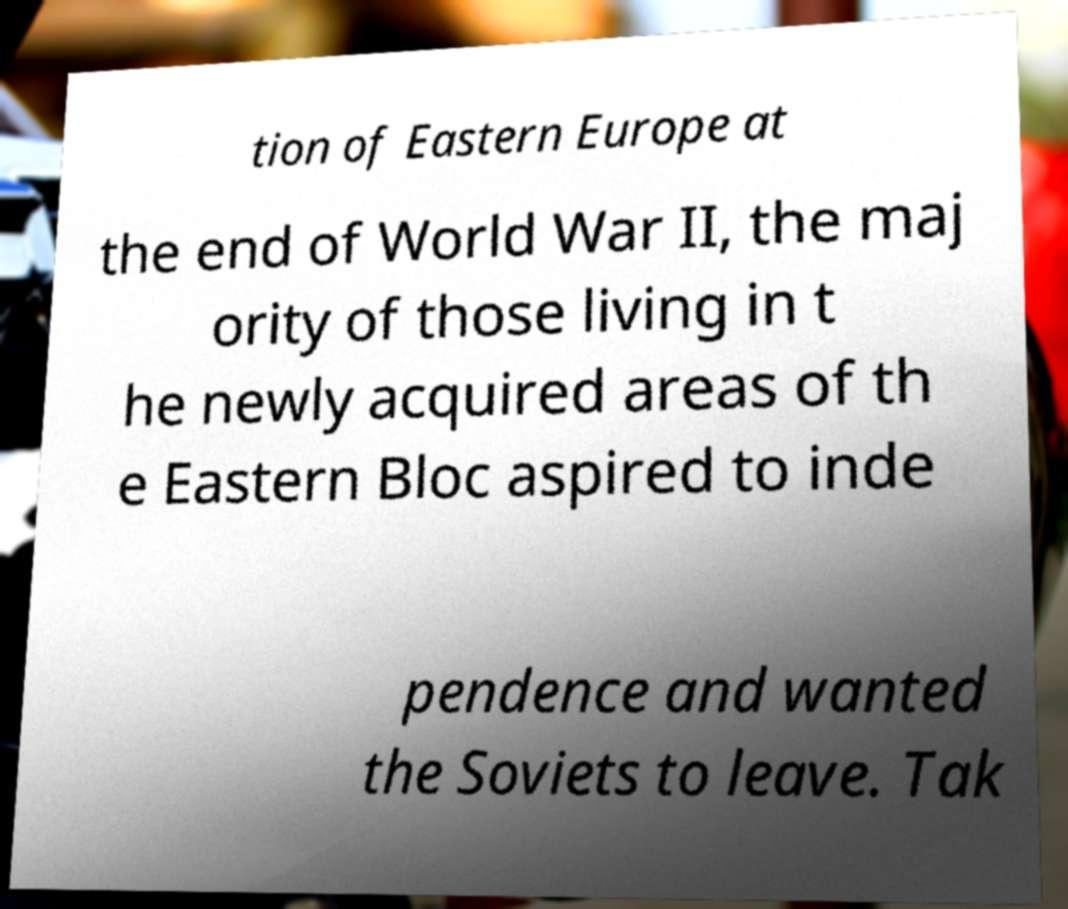For documentation purposes, I need the text within this image transcribed. Could you provide that? tion of Eastern Europe at the end of World War II, the maj ority of those living in t he newly acquired areas of th e Eastern Bloc aspired to inde pendence and wanted the Soviets to leave. Tak 